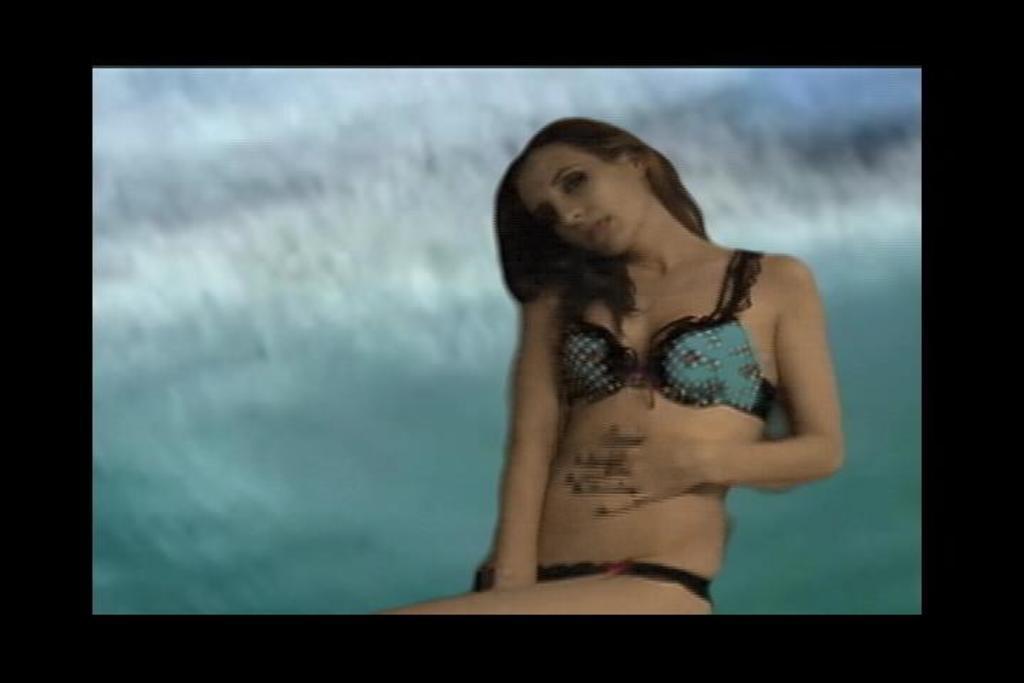Describe this image in one or two sentences. In this picture we can see a woman and there is a blur background. 